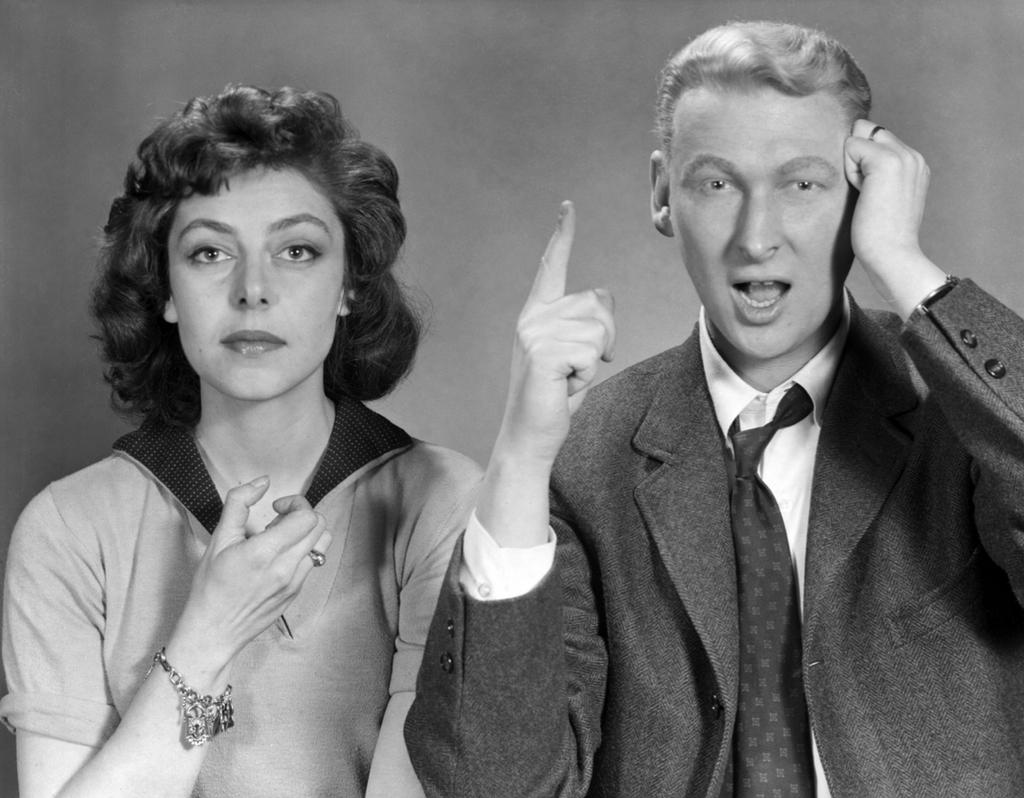How many people are in the image? There are two people in the image, a woman and a man. What is the man wearing in the image? The man is wearing a coat and a tie in the image. How many chairs are visible in the image? There are no chairs visible in the image; it only features a woman and a man. What type of skirt is the man wearing in the image? The man is not wearing a skirt in the image; he is wearing a coat and a tie. 